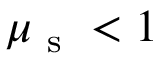Convert formula to latex. <formula><loc_0><loc_0><loc_500><loc_500>\mu _ { s } < 1</formula> 